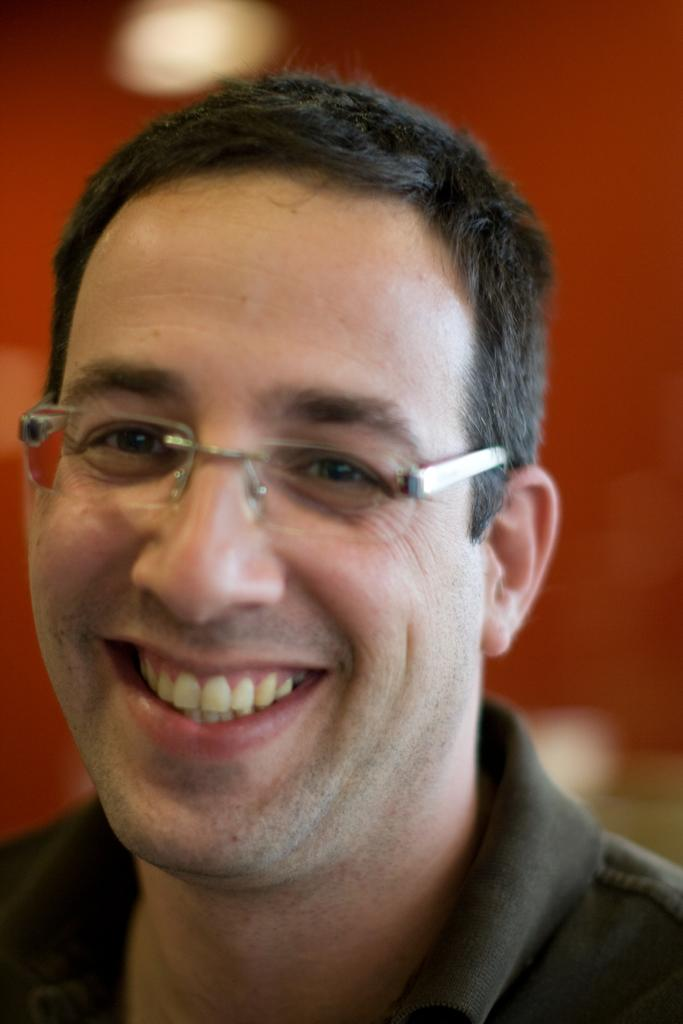Who is the main subject in the image? There is a man in the center of the image. Can you describe the background of the image? The background of the image is blurry. What type of flower can be seen on the page in the image? There is no flower or page present in the image; it features a man in the center with a blurry background. 